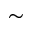<formula> <loc_0><loc_0><loc_500><loc_500>\sim</formula> 